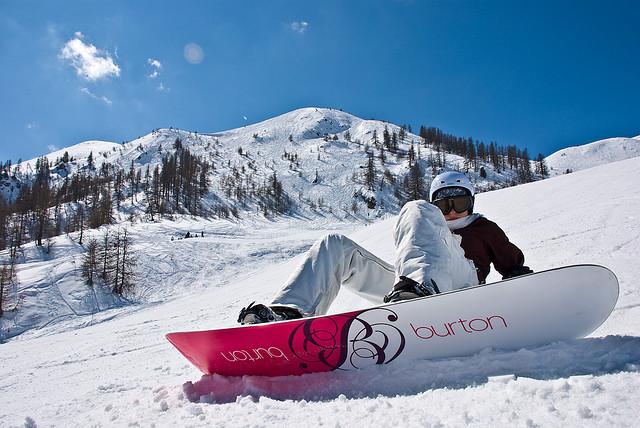Is he skating?
Short answer required. No. What is the name on the board?
Write a very short answer. Burton. What color is the board?
Write a very short answer. Red and white. 